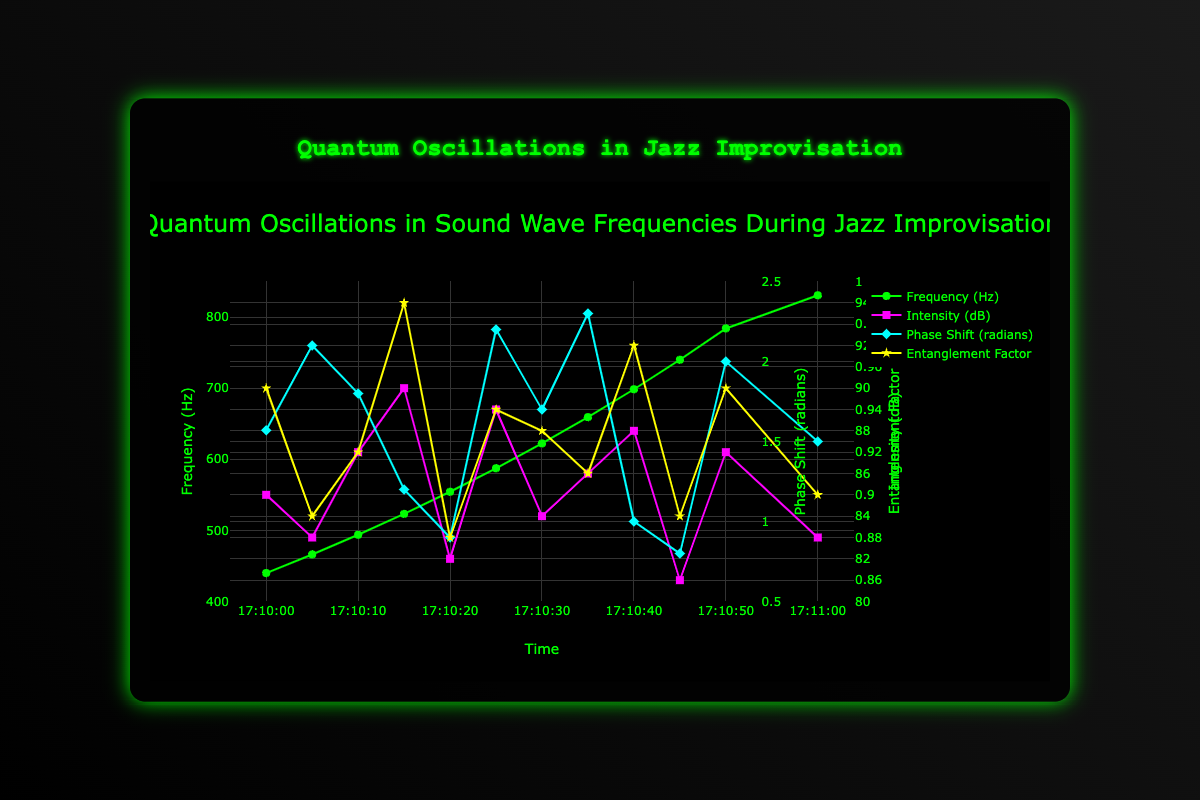What is the range of frequencies observed during the jazz improvisation? The range of a set of values is found by subtracting the smallest value from the largest value. Here, the smallest frequency is 440.0 Hz and the largest is 830.61 Hz. Therefore, the range is 830.61 - 440.0 = 390.61 Hz.
Answer: 390.61 Hz At what time did the highest intensity (dB) occur, and what was that intensity value? The highest intensity value is 90 dB which occurs at timestamp "2023-10-01T00:10:15Z".
Answer: 2023-10-01T00:10:15Z, 90 dB How does the phase shift at timestamp "2023-10-01T00:10:50Z" compare with the phase shift at "2023-10-01T00:10:25Z"? At "2023-10-01T00:10:50Z", the phase shift is 2.0 radians, and at "2023-10-01T00:10:25Z" the phase shift is 2.2 radians. Therefore, the phase shift at "2023-10-01T00:10:50Z" is less than at "2023-10-01T00:10:25Z".
Answer: Less What is the average entanglement factor for all the time points? To find the average entanglement factor, sum all the entanglement factors and divide by the number of time points. Summing them gives 0.95 + 0.89 + 0.92 + 0.99 + 0.88 + 0.94 + 0.93 + 0.91 + 0.97 + 0.89 + 0.95 + 0.90 = 11.12. There are 12 time points, so the average is 11.12 / 12 = 0.9267.
Answer: 0.9267 Which note has the maximum phase shift, and what is its corresponding timestamp? The note with the maximum phase shift is D5, which has a phase shift of 2.3 radians at timestamp "2023-10-01T00:10:35Z".
Answer: D5, 2023-10-01T00:10:35Z What is the difference in intensity (dB) between the notes F#5 and G5? The intensity for F#5 is 81 dB and for G5 is 87 dB. Therefore, the difference is 87 - 81 = 6 dB.
Answer: 6 dB Identify the timestamp when the frequency crosses 600 Hz for the first time. What is the entanglement factor at that timestamp? The first time the frequency exceeds 600 Hz is at timestamp "2023-10-01T00:10:30Z" with a frequency of 622.25 Hz. The entanglement factor at this timestamp is 0.93.
Answer: 2023-10-01T00:10:30Z, 0.93 Compare the entanglement factors at the timestamps where the phase shifts are 1.57 radians and 0.8 radians. Which one is higher? The phase shift of 1.57 radians corresponds to an entanglement factor of 0.95, and the phase shift of 0.8 radians corresponds to an entanglement factor of 0.89. The entanglement factor for 1.57 radians is higher.
Answer: 1.57 radians 